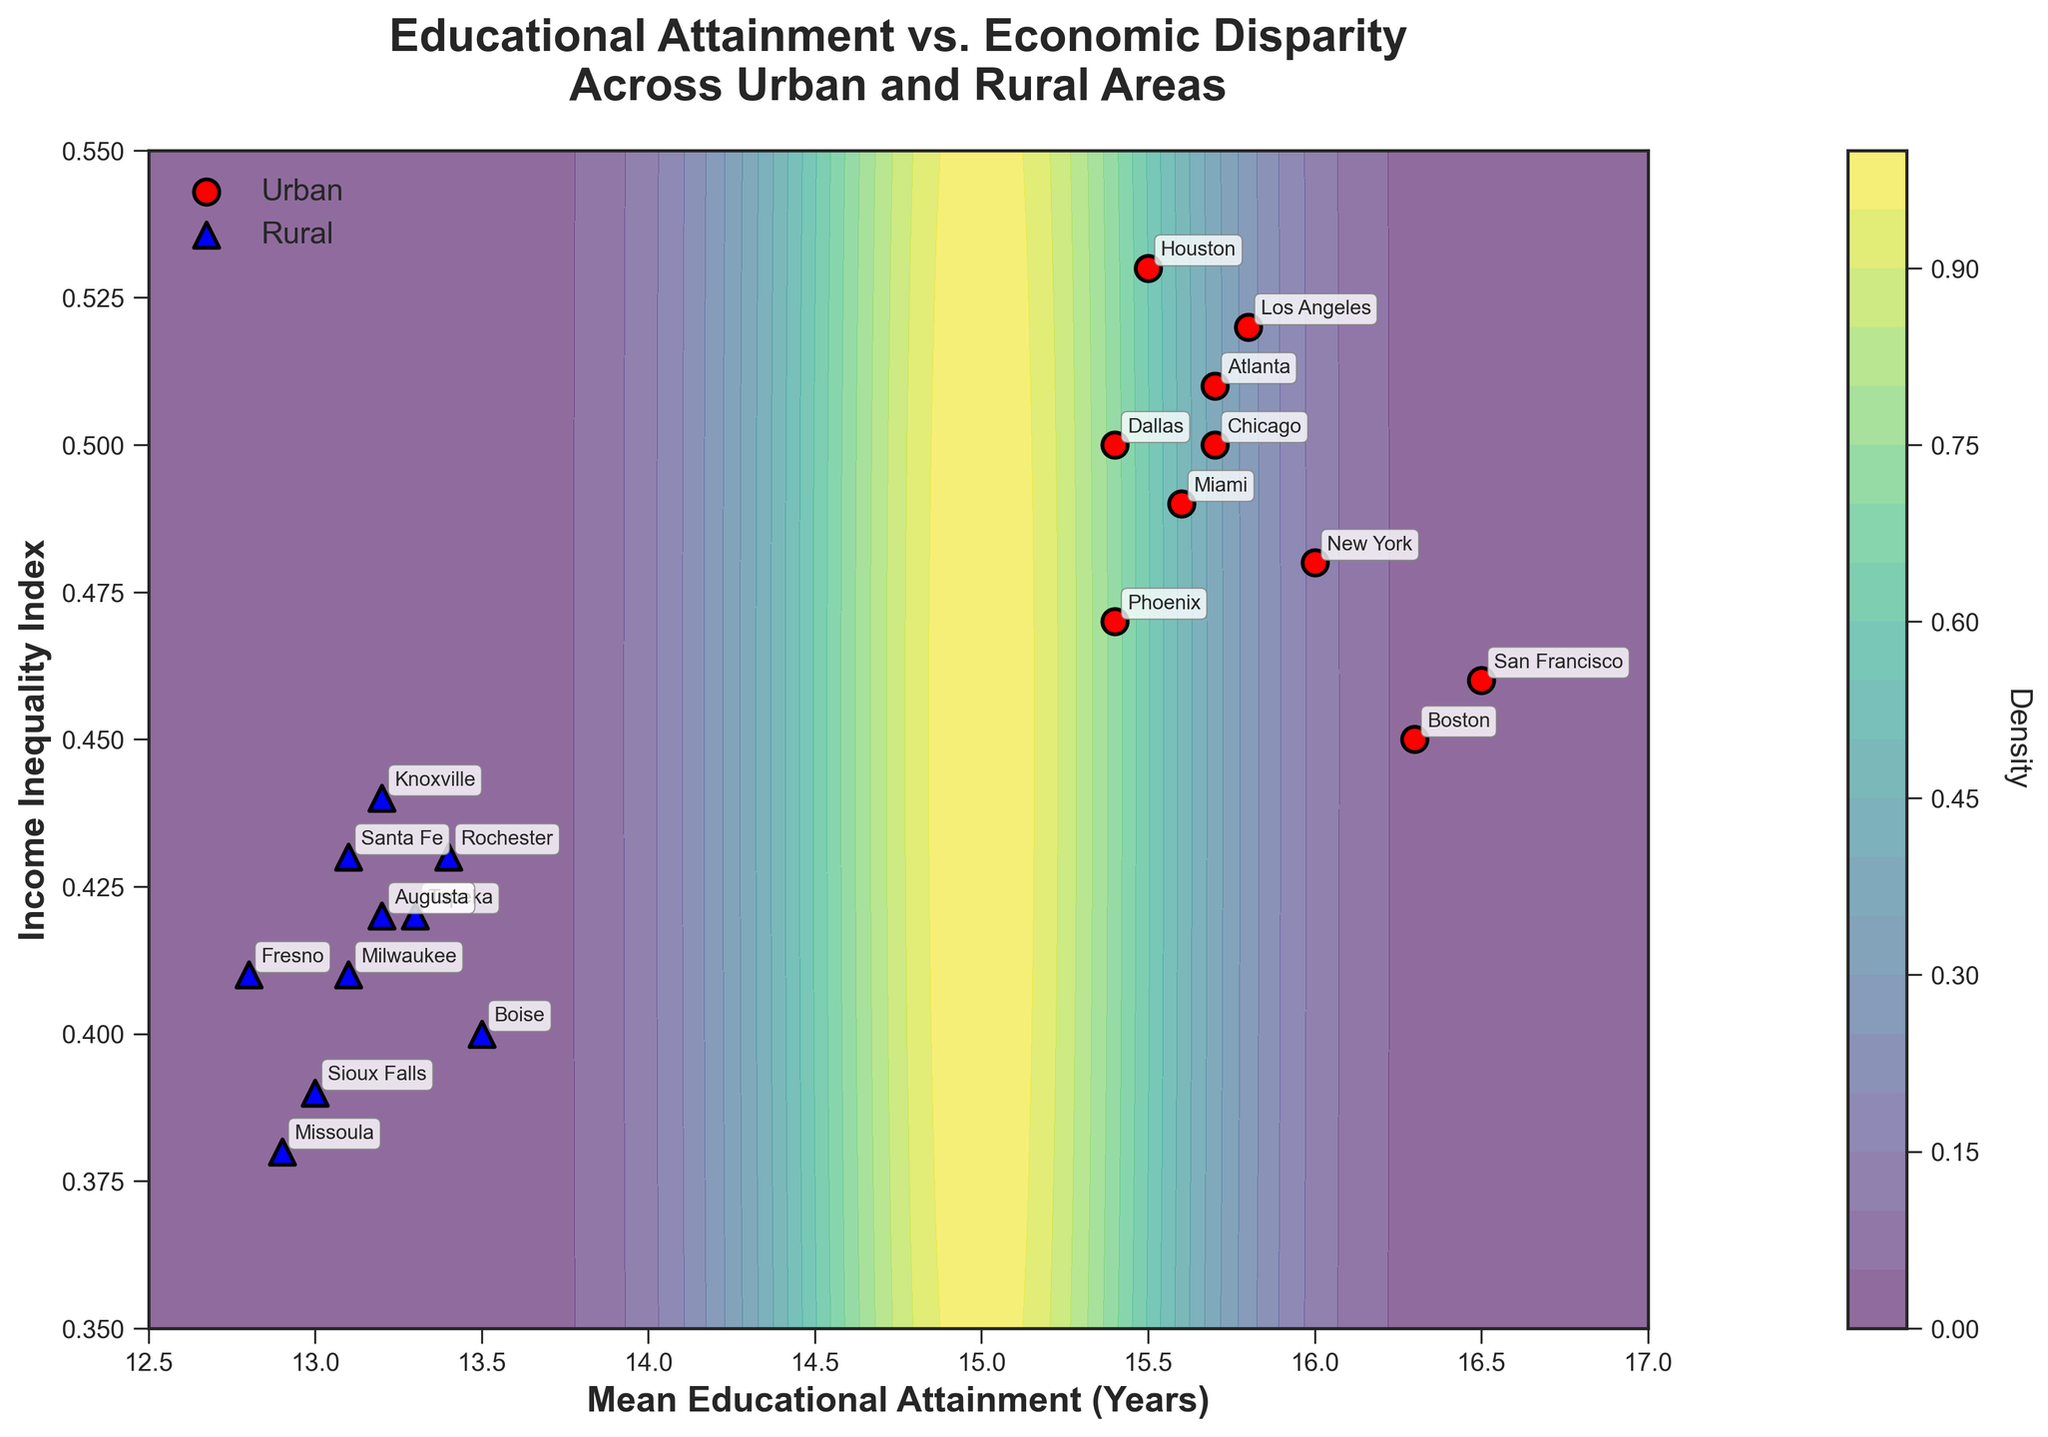What is the title of the figure? The title is prominently displayed at the top of the figure and reads "Educational Attainment vs. Economic Disparity Across Urban and Rural Areas."
Answer: Educational Attainment vs. Economic Disparity Across Urban and Rural Areas How many urban and rural data points are shown in the figure? The urban data points are represented by red circles, and the rural data points are represented by blue triangles. By counting each, there are 10 urban data points and 9 rural data points.
Answer: 10 urban, 9 rural What is the range of the Income Inequality Index in the plot? The y-axis represents the Income Inequality Index and ranges from 0.35 to 0.55, as can be seen from the axis ticks and labels.
Answer: 0.35 to 0.55 Which urban area has the highest mean educational attainment? The urban area with the highest mean educational attainment will have the highest x-value among the urban points (red circles). San Francisco, with a mean educational attainment of 16.5 years, has the highest value.
Answer: San Francisco Compare the income inequality index between New York and Boston. Which one is higher? New York is one of the urban data points (red circle) located at (16, 0.48) and Boston at (16.3, 0.45). The y-value of 0.48 for New York is higher than 0.45 for Boston.
Answer: New York What is the average mean educational attainment for rural areas? Sum the mean educational attainment values for rural areas: (12.8 + 13.1 + 13.5 + 13.3 + 13.0 + 12.9 + 13.2 + 13.1 + 13.4 + 13.2) = 129.5. Divide by the number of rural areas (9): 129.5 / 9 = 13.1 years.
Answer: 13.1 years Which location has the lowest income inequality index? The location with the lowest y-value (Income Inequality Index) among all data points. Missoula, with an index of 0.38, has the lowest value.
Answer: Missoula How does the income inequality index generally compare between urban and rural areas? Visually observe the y-values for red circles (urban) and blue triangles (rural). Generally, urban areas (red) have higher income inequality index values, spread between 0.45 to 0.53, while rural areas (blue) range lower, mainly between 0.38 to 0.44.
Answer: Higher for urban Is there a visible trend or correlation between educational attainment and income inequality? Observing the contour and scatter plot, areas with higher mean educational attainment (to the right) tend to have varying income inequality but a cluster suggests less inequality (lower y-value) aligns with higher educational attainment.
Answer: Yes, less inequality with higher educational attainment 